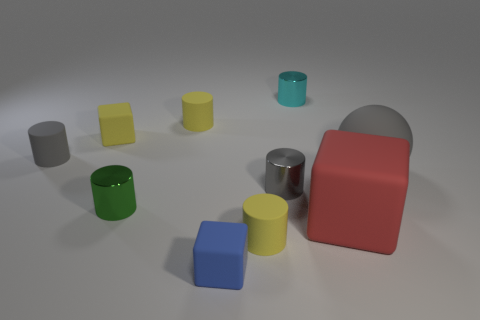Subtract all small green cylinders. How many cylinders are left? 5 Subtract all yellow blocks. How many blocks are left? 2 Subtract all cylinders. How many objects are left? 4 Subtract all purple spheres. How many green cylinders are left? 1 Subtract all cyan cylinders. Subtract all large red matte blocks. How many objects are left? 8 Add 4 small yellow cylinders. How many small yellow cylinders are left? 6 Add 5 yellow rubber things. How many yellow rubber things exist? 8 Subtract 0 cyan balls. How many objects are left? 10 Subtract 4 cylinders. How many cylinders are left? 2 Subtract all purple cylinders. Subtract all gray blocks. How many cylinders are left? 6 